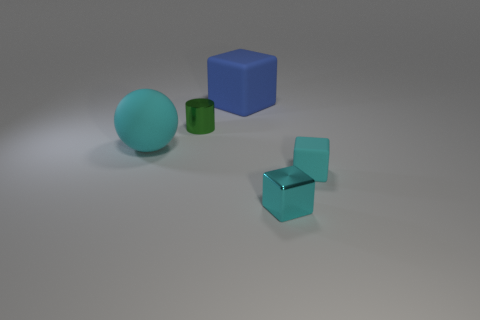There is a big thing that is behind the small object behind the large cyan object; is there a cyan rubber sphere that is on the left side of it?
Keep it short and to the point. Yes. What number of other things are made of the same material as the large cyan thing?
Offer a very short reply. 2. What number of large cyan shiny cubes are there?
Provide a short and direct response. 0. What number of objects are either big brown things or cyan cubes behind the small cyan metallic thing?
Give a very brief answer. 1. Are there any other things that have the same shape as the cyan metal thing?
Your answer should be very brief. Yes. There is a cyan matte object that is on the left side of the shiny cylinder; does it have the same size as the small shiny block?
Give a very brief answer. No. What number of metallic things are either tiny yellow cylinders or tiny green things?
Your answer should be very brief. 1. What is the size of the matte block on the right side of the big blue cube?
Your answer should be very brief. Small. Does the large blue object have the same shape as the small green metallic thing?
Provide a short and direct response. No. How many small things are blue objects or balls?
Provide a short and direct response. 0. 